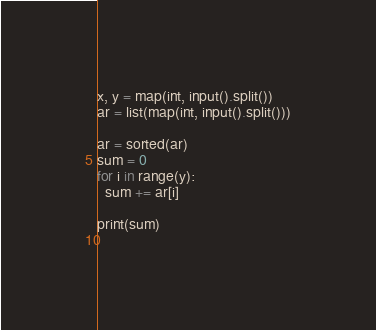<code> <loc_0><loc_0><loc_500><loc_500><_Python_>x, y = map(int, input().split())
ar = list(map(int, input().split()))

ar = sorted(ar)
sum = 0
for i in range(y):
  sum += ar[i]
  
print(sum)
  </code> 